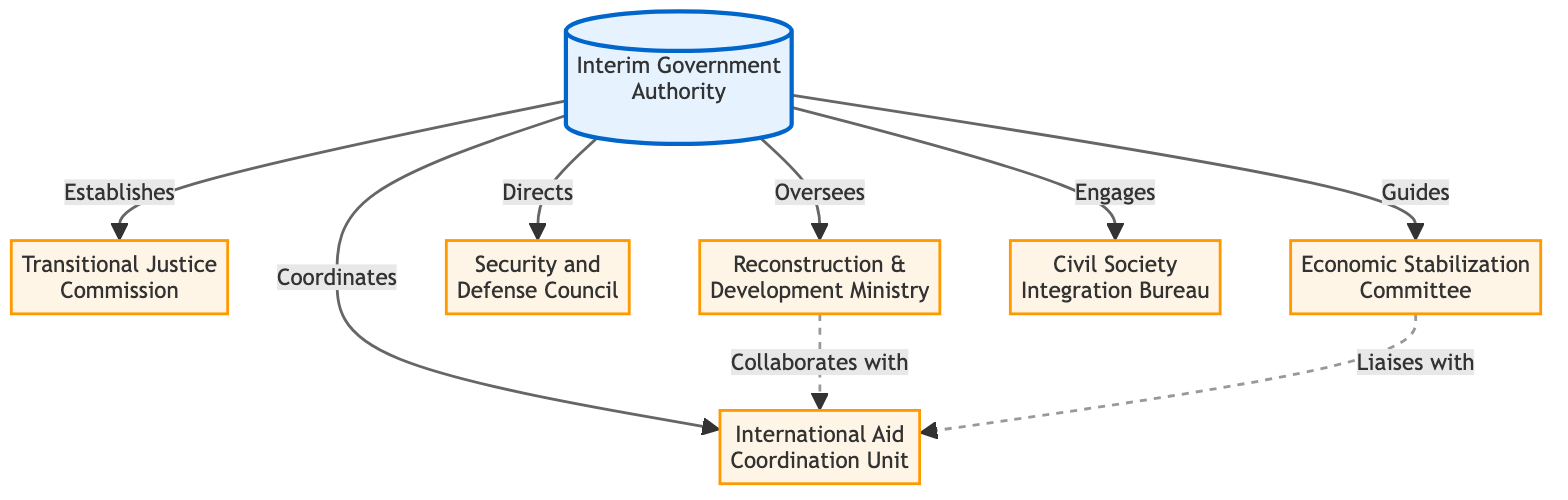What is the top node in the hierarchy? The top node, which represents the overall authority in the administrative organization, is labeled "Interim Government Authority."
Answer: Interim Government Authority How many nodes are there in total? Counting each distinct entity in the diagram gives a total of seven nodes: one root node and six subordinate nodes.
Answer: 7 Which node is connected to the "Reconstruction & Development Ministry"? The "Reconstruction & Development Ministry" is directly connected to the "Interim Government Authority," which oversees it.
Answer: Interim Government Authority What type of relationship is shown between the "Economic Stabilization Committee" and the "International Aid Coordination Unit"? The diagram shows a dashed line connecting these two nodes, indicating a liaison type of relationship, characterized by informal or advisory interaction.
Answer: Liaises with How many organizations report directly to the "Interim Government Authority"? There are six organizations that report directly to the "Interim Government Authority," as indicated by the direct arrows from the root node to each of these six nodes.
Answer: 6 Which node collaborates with the "International Aid Coordination Unit"? The "Reconstruction & Development Ministry" collaborates with the "International Aid Coordination Unit," as reflected by the dashed arrow connecting these two nodes.
Answer: Reconstruction & Development Ministry What is the relationship type between the "Civil Society Integration Bureau" and the "Interim Government Authority"? The "Civil Society Integration Bureau" is engaged by the "Interim Government Authority," indicating a guiding or supporting role from the authority to the bureau.
Answer: Engages Which node does not have a solid arrow connection? Both the "International Aid Coordination Unit" and the "Economic Stabilization Committee" have dashed arrow connections, indicating non-direct relationships with the "Reconstruction & Development Ministry."
Answer: International Aid Coordination Unit What is the role of the "Transitional Justice Commission"? The "Transitional Justice Commission" is established by the "Interim Government Authority," playing a significant role in the transitional justice process following conflict.
Answer: Established 